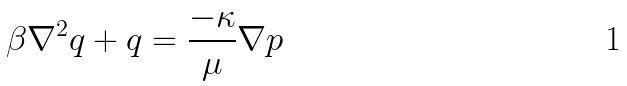<formula> <loc_0><loc_0><loc_500><loc_500>\beta \nabla ^ { 2 } q + q = \frac { - \kappa } { \mu } \nabla p</formula> 